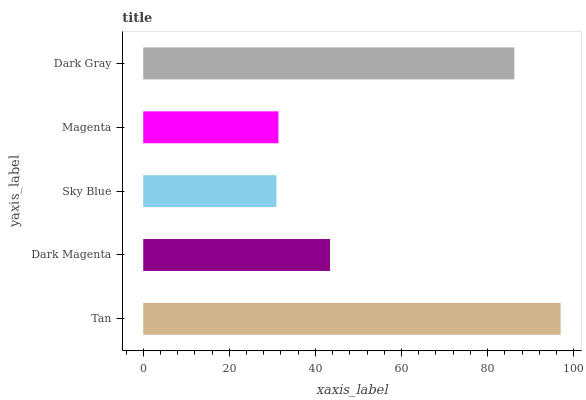Is Sky Blue the minimum?
Answer yes or no. Yes. Is Tan the maximum?
Answer yes or no. Yes. Is Dark Magenta the minimum?
Answer yes or no. No. Is Dark Magenta the maximum?
Answer yes or no. No. Is Tan greater than Dark Magenta?
Answer yes or no. Yes. Is Dark Magenta less than Tan?
Answer yes or no. Yes. Is Dark Magenta greater than Tan?
Answer yes or no. No. Is Tan less than Dark Magenta?
Answer yes or no. No. Is Dark Magenta the high median?
Answer yes or no. Yes. Is Dark Magenta the low median?
Answer yes or no. Yes. Is Dark Gray the high median?
Answer yes or no. No. Is Magenta the low median?
Answer yes or no. No. 